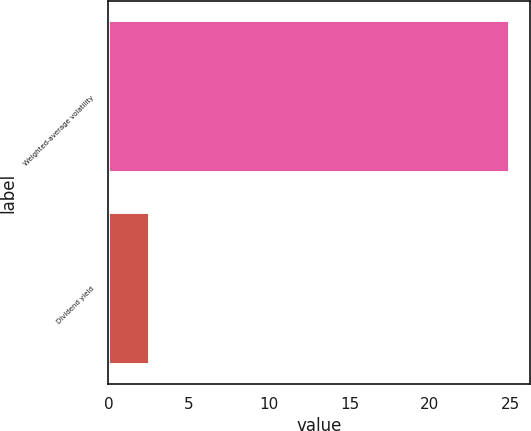<chart> <loc_0><loc_0><loc_500><loc_500><bar_chart><fcel>Weighted-average volatility<fcel>Dividend yield<nl><fcel>25<fcel>2.61<nl></chart> 